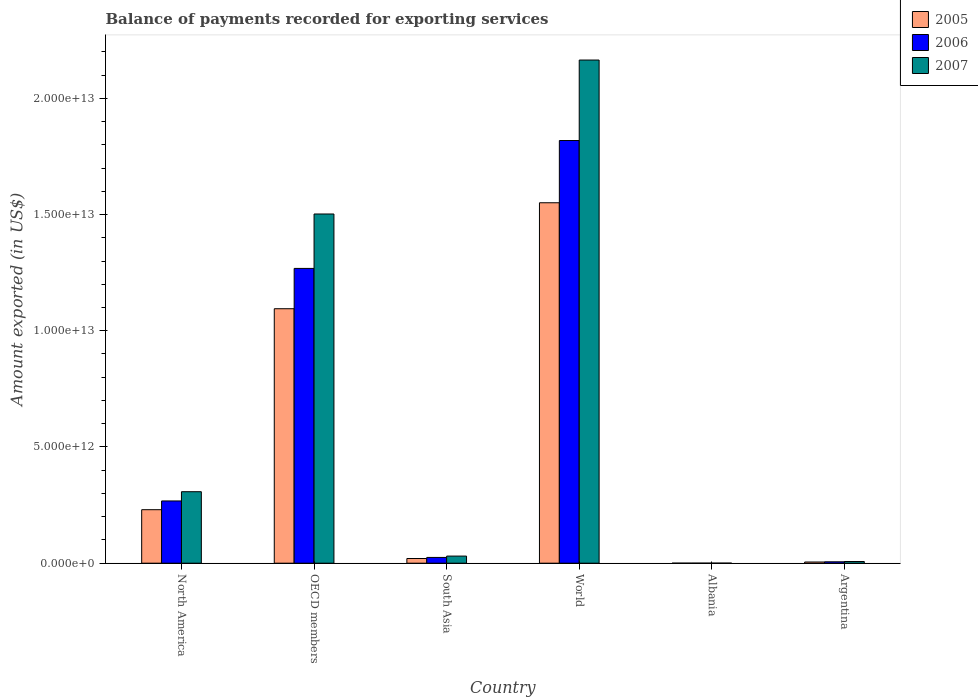Are the number of bars per tick equal to the number of legend labels?
Offer a terse response. Yes. Are the number of bars on each tick of the X-axis equal?
Offer a very short reply. Yes. What is the label of the 3rd group of bars from the left?
Your response must be concise. South Asia. What is the amount exported in 2007 in Albania?
Your answer should be compact. 2.85e+09. Across all countries, what is the maximum amount exported in 2007?
Offer a very short reply. 2.16e+13. Across all countries, what is the minimum amount exported in 2006?
Provide a succinct answer. 2.20e+09. In which country was the amount exported in 2007 minimum?
Give a very brief answer. Albania. What is the total amount exported in 2005 in the graph?
Ensure brevity in your answer.  2.90e+13. What is the difference between the amount exported in 2006 in Albania and that in Argentina?
Your answer should be compact. -5.79e+1. What is the difference between the amount exported in 2007 in World and the amount exported in 2006 in South Asia?
Your response must be concise. 2.14e+13. What is the average amount exported in 2007 per country?
Offer a very short reply. 6.69e+12. What is the difference between the amount exported of/in 2006 and amount exported of/in 2005 in OECD members?
Your response must be concise. 1.73e+12. In how many countries, is the amount exported in 2006 greater than 6000000000000 US$?
Offer a very short reply. 2. What is the ratio of the amount exported in 2006 in Albania to that in Argentina?
Keep it short and to the point. 0.04. Is the amount exported in 2007 in OECD members less than that in World?
Your response must be concise. Yes. Is the difference between the amount exported in 2006 in Albania and North America greater than the difference between the amount exported in 2005 in Albania and North America?
Make the answer very short. No. What is the difference between the highest and the second highest amount exported in 2006?
Provide a succinct answer. 5.50e+12. What is the difference between the highest and the lowest amount exported in 2007?
Offer a very short reply. 2.16e+13. Is the sum of the amount exported in 2005 in Argentina and World greater than the maximum amount exported in 2007 across all countries?
Offer a terse response. No. What does the 3rd bar from the left in South Asia represents?
Provide a short and direct response. 2007. What does the 3rd bar from the right in Argentina represents?
Give a very brief answer. 2005. Are all the bars in the graph horizontal?
Provide a short and direct response. No. How many countries are there in the graph?
Offer a very short reply. 6. What is the difference between two consecutive major ticks on the Y-axis?
Your answer should be compact. 5.00e+12. Are the values on the major ticks of Y-axis written in scientific E-notation?
Make the answer very short. Yes. Does the graph contain any zero values?
Offer a very short reply. No. Where does the legend appear in the graph?
Give a very brief answer. Top right. How many legend labels are there?
Make the answer very short. 3. What is the title of the graph?
Give a very brief answer. Balance of payments recorded for exporting services. Does "1962" appear as one of the legend labels in the graph?
Offer a terse response. No. What is the label or title of the X-axis?
Provide a short and direct response. Country. What is the label or title of the Y-axis?
Provide a succinct answer. Amount exported (in US$). What is the Amount exported (in US$) in 2005 in North America?
Keep it short and to the point. 2.30e+12. What is the Amount exported (in US$) of 2006 in North America?
Provide a short and direct response. 2.68e+12. What is the Amount exported (in US$) of 2007 in North America?
Provide a short and direct response. 3.08e+12. What is the Amount exported (in US$) of 2005 in OECD members?
Ensure brevity in your answer.  1.09e+13. What is the Amount exported (in US$) of 2006 in OECD members?
Keep it short and to the point. 1.27e+13. What is the Amount exported (in US$) of 2007 in OECD members?
Offer a terse response. 1.50e+13. What is the Amount exported (in US$) of 2005 in South Asia?
Keep it short and to the point. 2.02e+11. What is the Amount exported (in US$) in 2006 in South Asia?
Your response must be concise. 2.48e+11. What is the Amount exported (in US$) in 2007 in South Asia?
Make the answer very short. 3.06e+11. What is the Amount exported (in US$) of 2005 in World?
Offer a terse response. 1.55e+13. What is the Amount exported (in US$) in 2006 in World?
Your response must be concise. 1.82e+13. What is the Amount exported (in US$) of 2007 in World?
Provide a short and direct response. 2.16e+13. What is the Amount exported (in US$) in 2005 in Albania?
Offer a very short reply. 1.69e+09. What is the Amount exported (in US$) in 2006 in Albania?
Provide a succinct answer. 2.20e+09. What is the Amount exported (in US$) of 2007 in Albania?
Offer a terse response. 2.85e+09. What is the Amount exported (in US$) of 2005 in Argentina?
Your answer should be very brief. 5.12e+1. What is the Amount exported (in US$) of 2006 in Argentina?
Give a very brief answer. 6.01e+1. What is the Amount exported (in US$) of 2007 in Argentina?
Make the answer very short. 7.28e+1. Across all countries, what is the maximum Amount exported (in US$) of 2005?
Your response must be concise. 1.55e+13. Across all countries, what is the maximum Amount exported (in US$) in 2006?
Keep it short and to the point. 1.82e+13. Across all countries, what is the maximum Amount exported (in US$) in 2007?
Provide a short and direct response. 2.16e+13. Across all countries, what is the minimum Amount exported (in US$) in 2005?
Provide a succinct answer. 1.69e+09. Across all countries, what is the minimum Amount exported (in US$) in 2006?
Offer a terse response. 2.20e+09. Across all countries, what is the minimum Amount exported (in US$) of 2007?
Your answer should be compact. 2.85e+09. What is the total Amount exported (in US$) of 2005 in the graph?
Provide a short and direct response. 2.90e+13. What is the total Amount exported (in US$) in 2006 in the graph?
Make the answer very short. 3.39e+13. What is the total Amount exported (in US$) in 2007 in the graph?
Provide a succinct answer. 4.01e+13. What is the difference between the Amount exported (in US$) of 2005 in North America and that in OECD members?
Your answer should be very brief. -8.65e+12. What is the difference between the Amount exported (in US$) of 2006 in North America and that in OECD members?
Your answer should be compact. -1.00e+13. What is the difference between the Amount exported (in US$) in 2007 in North America and that in OECD members?
Your answer should be compact. -1.19e+13. What is the difference between the Amount exported (in US$) of 2005 in North America and that in South Asia?
Ensure brevity in your answer.  2.10e+12. What is the difference between the Amount exported (in US$) of 2006 in North America and that in South Asia?
Offer a very short reply. 2.43e+12. What is the difference between the Amount exported (in US$) of 2007 in North America and that in South Asia?
Give a very brief answer. 2.77e+12. What is the difference between the Amount exported (in US$) of 2005 in North America and that in World?
Make the answer very short. -1.32e+13. What is the difference between the Amount exported (in US$) in 2006 in North America and that in World?
Provide a succinct answer. -1.55e+13. What is the difference between the Amount exported (in US$) of 2007 in North America and that in World?
Offer a terse response. -1.86e+13. What is the difference between the Amount exported (in US$) of 2005 in North America and that in Albania?
Offer a terse response. 2.30e+12. What is the difference between the Amount exported (in US$) in 2006 in North America and that in Albania?
Your answer should be compact. 2.68e+12. What is the difference between the Amount exported (in US$) of 2007 in North America and that in Albania?
Your answer should be compact. 3.07e+12. What is the difference between the Amount exported (in US$) in 2005 in North America and that in Argentina?
Keep it short and to the point. 2.25e+12. What is the difference between the Amount exported (in US$) in 2006 in North America and that in Argentina?
Your response must be concise. 2.62e+12. What is the difference between the Amount exported (in US$) in 2007 in North America and that in Argentina?
Give a very brief answer. 3.00e+12. What is the difference between the Amount exported (in US$) in 2005 in OECD members and that in South Asia?
Your response must be concise. 1.07e+13. What is the difference between the Amount exported (in US$) of 2006 in OECD members and that in South Asia?
Offer a very short reply. 1.24e+13. What is the difference between the Amount exported (in US$) of 2007 in OECD members and that in South Asia?
Provide a succinct answer. 1.47e+13. What is the difference between the Amount exported (in US$) of 2005 in OECD members and that in World?
Give a very brief answer. -4.56e+12. What is the difference between the Amount exported (in US$) of 2006 in OECD members and that in World?
Give a very brief answer. -5.50e+12. What is the difference between the Amount exported (in US$) of 2007 in OECD members and that in World?
Your response must be concise. -6.62e+12. What is the difference between the Amount exported (in US$) of 2005 in OECD members and that in Albania?
Your answer should be compact. 1.09e+13. What is the difference between the Amount exported (in US$) in 2006 in OECD members and that in Albania?
Offer a very short reply. 1.27e+13. What is the difference between the Amount exported (in US$) of 2007 in OECD members and that in Albania?
Offer a very short reply. 1.50e+13. What is the difference between the Amount exported (in US$) in 2005 in OECD members and that in Argentina?
Make the answer very short. 1.09e+13. What is the difference between the Amount exported (in US$) of 2006 in OECD members and that in Argentina?
Ensure brevity in your answer.  1.26e+13. What is the difference between the Amount exported (in US$) of 2007 in OECD members and that in Argentina?
Your response must be concise. 1.50e+13. What is the difference between the Amount exported (in US$) of 2005 in South Asia and that in World?
Keep it short and to the point. -1.53e+13. What is the difference between the Amount exported (in US$) in 2006 in South Asia and that in World?
Your answer should be very brief. -1.79e+13. What is the difference between the Amount exported (in US$) in 2007 in South Asia and that in World?
Offer a terse response. -2.13e+13. What is the difference between the Amount exported (in US$) in 2005 in South Asia and that in Albania?
Provide a succinct answer. 2.00e+11. What is the difference between the Amount exported (in US$) of 2006 in South Asia and that in Albania?
Your answer should be very brief. 2.46e+11. What is the difference between the Amount exported (in US$) in 2007 in South Asia and that in Albania?
Keep it short and to the point. 3.03e+11. What is the difference between the Amount exported (in US$) in 2005 in South Asia and that in Argentina?
Provide a short and direct response. 1.51e+11. What is the difference between the Amount exported (in US$) in 2006 in South Asia and that in Argentina?
Your response must be concise. 1.88e+11. What is the difference between the Amount exported (in US$) in 2007 in South Asia and that in Argentina?
Ensure brevity in your answer.  2.33e+11. What is the difference between the Amount exported (in US$) of 2005 in World and that in Albania?
Keep it short and to the point. 1.55e+13. What is the difference between the Amount exported (in US$) in 2006 in World and that in Albania?
Your answer should be very brief. 1.82e+13. What is the difference between the Amount exported (in US$) in 2007 in World and that in Albania?
Offer a very short reply. 2.16e+13. What is the difference between the Amount exported (in US$) of 2005 in World and that in Argentina?
Give a very brief answer. 1.55e+13. What is the difference between the Amount exported (in US$) of 2006 in World and that in Argentina?
Your answer should be compact. 1.81e+13. What is the difference between the Amount exported (in US$) in 2007 in World and that in Argentina?
Provide a short and direct response. 2.16e+13. What is the difference between the Amount exported (in US$) of 2005 in Albania and that in Argentina?
Your answer should be compact. -4.95e+1. What is the difference between the Amount exported (in US$) of 2006 in Albania and that in Argentina?
Keep it short and to the point. -5.79e+1. What is the difference between the Amount exported (in US$) of 2007 in Albania and that in Argentina?
Your answer should be compact. -6.99e+1. What is the difference between the Amount exported (in US$) in 2005 in North America and the Amount exported (in US$) in 2006 in OECD members?
Give a very brief answer. -1.04e+13. What is the difference between the Amount exported (in US$) of 2005 in North America and the Amount exported (in US$) of 2007 in OECD members?
Provide a succinct answer. -1.27e+13. What is the difference between the Amount exported (in US$) in 2006 in North America and the Amount exported (in US$) in 2007 in OECD members?
Provide a succinct answer. -1.23e+13. What is the difference between the Amount exported (in US$) in 2005 in North America and the Amount exported (in US$) in 2006 in South Asia?
Ensure brevity in your answer.  2.05e+12. What is the difference between the Amount exported (in US$) in 2005 in North America and the Amount exported (in US$) in 2007 in South Asia?
Keep it short and to the point. 2.00e+12. What is the difference between the Amount exported (in US$) in 2006 in North America and the Amount exported (in US$) in 2007 in South Asia?
Offer a terse response. 2.37e+12. What is the difference between the Amount exported (in US$) in 2005 in North America and the Amount exported (in US$) in 2006 in World?
Ensure brevity in your answer.  -1.59e+13. What is the difference between the Amount exported (in US$) of 2005 in North America and the Amount exported (in US$) of 2007 in World?
Offer a very short reply. -1.93e+13. What is the difference between the Amount exported (in US$) of 2006 in North America and the Amount exported (in US$) of 2007 in World?
Keep it short and to the point. -1.90e+13. What is the difference between the Amount exported (in US$) of 2005 in North America and the Amount exported (in US$) of 2006 in Albania?
Offer a very short reply. 2.30e+12. What is the difference between the Amount exported (in US$) of 2005 in North America and the Amount exported (in US$) of 2007 in Albania?
Give a very brief answer. 2.30e+12. What is the difference between the Amount exported (in US$) in 2006 in North America and the Amount exported (in US$) in 2007 in Albania?
Make the answer very short. 2.68e+12. What is the difference between the Amount exported (in US$) of 2005 in North America and the Amount exported (in US$) of 2006 in Argentina?
Your answer should be very brief. 2.24e+12. What is the difference between the Amount exported (in US$) of 2005 in North America and the Amount exported (in US$) of 2007 in Argentina?
Offer a terse response. 2.23e+12. What is the difference between the Amount exported (in US$) of 2006 in North America and the Amount exported (in US$) of 2007 in Argentina?
Your answer should be compact. 2.61e+12. What is the difference between the Amount exported (in US$) of 2005 in OECD members and the Amount exported (in US$) of 2006 in South Asia?
Your answer should be compact. 1.07e+13. What is the difference between the Amount exported (in US$) of 2005 in OECD members and the Amount exported (in US$) of 2007 in South Asia?
Your response must be concise. 1.06e+13. What is the difference between the Amount exported (in US$) of 2006 in OECD members and the Amount exported (in US$) of 2007 in South Asia?
Keep it short and to the point. 1.24e+13. What is the difference between the Amount exported (in US$) in 2005 in OECD members and the Amount exported (in US$) in 2006 in World?
Your answer should be compact. -7.24e+12. What is the difference between the Amount exported (in US$) of 2005 in OECD members and the Amount exported (in US$) of 2007 in World?
Provide a short and direct response. -1.07e+13. What is the difference between the Amount exported (in US$) of 2006 in OECD members and the Amount exported (in US$) of 2007 in World?
Your response must be concise. -8.96e+12. What is the difference between the Amount exported (in US$) in 2005 in OECD members and the Amount exported (in US$) in 2006 in Albania?
Provide a short and direct response. 1.09e+13. What is the difference between the Amount exported (in US$) in 2005 in OECD members and the Amount exported (in US$) in 2007 in Albania?
Your answer should be very brief. 1.09e+13. What is the difference between the Amount exported (in US$) of 2006 in OECD members and the Amount exported (in US$) of 2007 in Albania?
Offer a terse response. 1.27e+13. What is the difference between the Amount exported (in US$) in 2005 in OECD members and the Amount exported (in US$) in 2006 in Argentina?
Offer a terse response. 1.09e+13. What is the difference between the Amount exported (in US$) in 2005 in OECD members and the Amount exported (in US$) in 2007 in Argentina?
Keep it short and to the point. 1.09e+13. What is the difference between the Amount exported (in US$) in 2006 in OECD members and the Amount exported (in US$) in 2007 in Argentina?
Make the answer very short. 1.26e+13. What is the difference between the Amount exported (in US$) of 2005 in South Asia and the Amount exported (in US$) of 2006 in World?
Your response must be concise. -1.80e+13. What is the difference between the Amount exported (in US$) of 2005 in South Asia and the Amount exported (in US$) of 2007 in World?
Your response must be concise. -2.14e+13. What is the difference between the Amount exported (in US$) in 2006 in South Asia and the Amount exported (in US$) in 2007 in World?
Give a very brief answer. -2.14e+13. What is the difference between the Amount exported (in US$) of 2005 in South Asia and the Amount exported (in US$) of 2006 in Albania?
Keep it short and to the point. 2.00e+11. What is the difference between the Amount exported (in US$) of 2005 in South Asia and the Amount exported (in US$) of 2007 in Albania?
Make the answer very short. 1.99e+11. What is the difference between the Amount exported (in US$) in 2006 in South Asia and the Amount exported (in US$) in 2007 in Albania?
Offer a very short reply. 2.45e+11. What is the difference between the Amount exported (in US$) of 2005 in South Asia and the Amount exported (in US$) of 2006 in Argentina?
Your answer should be very brief. 1.42e+11. What is the difference between the Amount exported (in US$) in 2005 in South Asia and the Amount exported (in US$) in 2007 in Argentina?
Keep it short and to the point. 1.29e+11. What is the difference between the Amount exported (in US$) in 2006 in South Asia and the Amount exported (in US$) in 2007 in Argentina?
Provide a short and direct response. 1.76e+11. What is the difference between the Amount exported (in US$) in 2005 in World and the Amount exported (in US$) in 2006 in Albania?
Offer a very short reply. 1.55e+13. What is the difference between the Amount exported (in US$) in 2005 in World and the Amount exported (in US$) in 2007 in Albania?
Your answer should be very brief. 1.55e+13. What is the difference between the Amount exported (in US$) in 2006 in World and the Amount exported (in US$) in 2007 in Albania?
Ensure brevity in your answer.  1.82e+13. What is the difference between the Amount exported (in US$) of 2005 in World and the Amount exported (in US$) of 2006 in Argentina?
Offer a very short reply. 1.54e+13. What is the difference between the Amount exported (in US$) of 2005 in World and the Amount exported (in US$) of 2007 in Argentina?
Your answer should be compact. 1.54e+13. What is the difference between the Amount exported (in US$) of 2006 in World and the Amount exported (in US$) of 2007 in Argentina?
Provide a succinct answer. 1.81e+13. What is the difference between the Amount exported (in US$) in 2005 in Albania and the Amount exported (in US$) in 2006 in Argentina?
Provide a short and direct response. -5.84e+1. What is the difference between the Amount exported (in US$) of 2005 in Albania and the Amount exported (in US$) of 2007 in Argentina?
Give a very brief answer. -7.11e+1. What is the difference between the Amount exported (in US$) in 2006 in Albania and the Amount exported (in US$) in 2007 in Argentina?
Your response must be concise. -7.06e+1. What is the average Amount exported (in US$) in 2005 per country?
Ensure brevity in your answer.  4.84e+12. What is the average Amount exported (in US$) in 2006 per country?
Your response must be concise. 5.64e+12. What is the average Amount exported (in US$) in 2007 per country?
Offer a very short reply. 6.69e+12. What is the difference between the Amount exported (in US$) of 2005 and Amount exported (in US$) of 2006 in North America?
Give a very brief answer. -3.76e+11. What is the difference between the Amount exported (in US$) in 2005 and Amount exported (in US$) in 2007 in North America?
Provide a succinct answer. -7.74e+11. What is the difference between the Amount exported (in US$) in 2006 and Amount exported (in US$) in 2007 in North America?
Give a very brief answer. -3.98e+11. What is the difference between the Amount exported (in US$) in 2005 and Amount exported (in US$) in 2006 in OECD members?
Offer a terse response. -1.73e+12. What is the difference between the Amount exported (in US$) of 2005 and Amount exported (in US$) of 2007 in OECD members?
Your answer should be compact. -4.07e+12. What is the difference between the Amount exported (in US$) in 2006 and Amount exported (in US$) in 2007 in OECD members?
Your answer should be compact. -2.34e+12. What is the difference between the Amount exported (in US$) of 2005 and Amount exported (in US$) of 2006 in South Asia?
Keep it short and to the point. -4.61e+1. What is the difference between the Amount exported (in US$) of 2005 and Amount exported (in US$) of 2007 in South Asia?
Offer a terse response. -1.04e+11. What is the difference between the Amount exported (in US$) in 2006 and Amount exported (in US$) in 2007 in South Asia?
Offer a very short reply. -5.78e+1. What is the difference between the Amount exported (in US$) in 2005 and Amount exported (in US$) in 2006 in World?
Ensure brevity in your answer.  -2.68e+12. What is the difference between the Amount exported (in US$) in 2005 and Amount exported (in US$) in 2007 in World?
Your answer should be very brief. -6.14e+12. What is the difference between the Amount exported (in US$) of 2006 and Amount exported (in US$) of 2007 in World?
Provide a succinct answer. -3.46e+12. What is the difference between the Amount exported (in US$) of 2005 and Amount exported (in US$) of 2006 in Albania?
Provide a short and direct response. -5.14e+08. What is the difference between the Amount exported (in US$) in 2005 and Amount exported (in US$) in 2007 in Albania?
Provide a succinct answer. -1.16e+09. What is the difference between the Amount exported (in US$) in 2006 and Amount exported (in US$) in 2007 in Albania?
Offer a very short reply. -6.45e+08. What is the difference between the Amount exported (in US$) of 2005 and Amount exported (in US$) of 2006 in Argentina?
Offer a very short reply. -8.91e+09. What is the difference between the Amount exported (in US$) of 2005 and Amount exported (in US$) of 2007 in Argentina?
Provide a short and direct response. -2.16e+1. What is the difference between the Amount exported (in US$) in 2006 and Amount exported (in US$) in 2007 in Argentina?
Your answer should be very brief. -1.27e+1. What is the ratio of the Amount exported (in US$) in 2005 in North America to that in OECD members?
Provide a succinct answer. 0.21. What is the ratio of the Amount exported (in US$) in 2006 in North America to that in OECD members?
Your answer should be very brief. 0.21. What is the ratio of the Amount exported (in US$) in 2007 in North America to that in OECD members?
Your response must be concise. 0.2. What is the ratio of the Amount exported (in US$) in 2005 in North America to that in South Asia?
Provide a short and direct response. 11.38. What is the ratio of the Amount exported (in US$) in 2006 in North America to that in South Asia?
Your answer should be very brief. 10.79. What is the ratio of the Amount exported (in US$) of 2007 in North America to that in South Asia?
Provide a succinct answer. 10.05. What is the ratio of the Amount exported (in US$) of 2005 in North America to that in World?
Provide a succinct answer. 0.15. What is the ratio of the Amount exported (in US$) of 2006 in North America to that in World?
Offer a terse response. 0.15. What is the ratio of the Amount exported (in US$) in 2007 in North America to that in World?
Make the answer very short. 0.14. What is the ratio of the Amount exported (in US$) of 2005 in North America to that in Albania?
Provide a succinct answer. 1363.97. What is the ratio of the Amount exported (in US$) of 2006 in North America to that in Albania?
Your answer should be compact. 1216.34. What is the ratio of the Amount exported (in US$) in 2007 in North America to that in Albania?
Your response must be concise. 1080.43. What is the ratio of the Amount exported (in US$) in 2005 in North America to that in Argentina?
Make the answer very short. 44.95. What is the ratio of the Amount exported (in US$) in 2006 in North America to that in Argentina?
Your response must be concise. 44.55. What is the ratio of the Amount exported (in US$) of 2007 in North America to that in Argentina?
Provide a succinct answer. 42.25. What is the ratio of the Amount exported (in US$) of 2005 in OECD members to that in South Asia?
Provide a succinct answer. 54.15. What is the ratio of the Amount exported (in US$) of 2006 in OECD members to that in South Asia?
Provide a succinct answer. 51.07. What is the ratio of the Amount exported (in US$) of 2007 in OECD members to that in South Asia?
Offer a very short reply. 49.07. What is the ratio of the Amount exported (in US$) of 2005 in OECD members to that in World?
Your answer should be very brief. 0.71. What is the ratio of the Amount exported (in US$) of 2006 in OECD members to that in World?
Your response must be concise. 0.7. What is the ratio of the Amount exported (in US$) in 2007 in OECD members to that in World?
Your answer should be very brief. 0.69. What is the ratio of the Amount exported (in US$) of 2005 in OECD members to that in Albania?
Offer a very short reply. 6487.86. What is the ratio of the Amount exported (in US$) in 2006 in OECD members to that in Albania?
Provide a short and direct response. 5759.92. What is the ratio of the Amount exported (in US$) of 2007 in OECD members to that in Albania?
Your response must be concise. 5277.04. What is the ratio of the Amount exported (in US$) in 2005 in OECD members to that in Argentina?
Your answer should be compact. 213.81. What is the ratio of the Amount exported (in US$) of 2006 in OECD members to that in Argentina?
Make the answer very short. 210.95. What is the ratio of the Amount exported (in US$) of 2007 in OECD members to that in Argentina?
Offer a terse response. 206.37. What is the ratio of the Amount exported (in US$) in 2005 in South Asia to that in World?
Your answer should be very brief. 0.01. What is the ratio of the Amount exported (in US$) of 2006 in South Asia to that in World?
Provide a short and direct response. 0.01. What is the ratio of the Amount exported (in US$) of 2007 in South Asia to that in World?
Offer a terse response. 0.01. What is the ratio of the Amount exported (in US$) of 2005 in South Asia to that in Albania?
Keep it short and to the point. 119.81. What is the ratio of the Amount exported (in US$) in 2006 in South Asia to that in Albania?
Your answer should be very brief. 112.78. What is the ratio of the Amount exported (in US$) in 2007 in South Asia to that in Albania?
Offer a terse response. 107.53. What is the ratio of the Amount exported (in US$) in 2005 in South Asia to that in Argentina?
Provide a succinct answer. 3.95. What is the ratio of the Amount exported (in US$) in 2006 in South Asia to that in Argentina?
Your response must be concise. 4.13. What is the ratio of the Amount exported (in US$) of 2007 in South Asia to that in Argentina?
Your answer should be very brief. 4.21. What is the ratio of the Amount exported (in US$) of 2005 in World to that in Albania?
Provide a short and direct response. 9189.13. What is the ratio of the Amount exported (in US$) of 2006 in World to that in Albania?
Provide a short and direct response. 8258.95. What is the ratio of the Amount exported (in US$) in 2007 in World to that in Albania?
Keep it short and to the point. 7603.71. What is the ratio of the Amount exported (in US$) in 2005 in World to that in Argentina?
Your answer should be very brief. 302.83. What is the ratio of the Amount exported (in US$) of 2006 in World to that in Argentina?
Offer a very short reply. 302.47. What is the ratio of the Amount exported (in US$) of 2007 in World to that in Argentina?
Provide a short and direct response. 297.37. What is the ratio of the Amount exported (in US$) of 2005 in Albania to that in Argentina?
Give a very brief answer. 0.03. What is the ratio of the Amount exported (in US$) in 2006 in Albania to that in Argentina?
Your answer should be compact. 0.04. What is the ratio of the Amount exported (in US$) of 2007 in Albania to that in Argentina?
Give a very brief answer. 0.04. What is the difference between the highest and the second highest Amount exported (in US$) in 2005?
Provide a short and direct response. 4.56e+12. What is the difference between the highest and the second highest Amount exported (in US$) in 2006?
Provide a succinct answer. 5.50e+12. What is the difference between the highest and the second highest Amount exported (in US$) in 2007?
Provide a short and direct response. 6.62e+12. What is the difference between the highest and the lowest Amount exported (in US$) of 2005?
Give a very brief answer. 1.55e+13. What is the difference between the highest and the lowest Amount exported (in US$) of 2006?
Provide a short and direct response. 1.82e+13. What is the difference between the highest and the lowest Amount exported (in US$) of 2007?
Your answer should be very brief. 2.16e+13. 